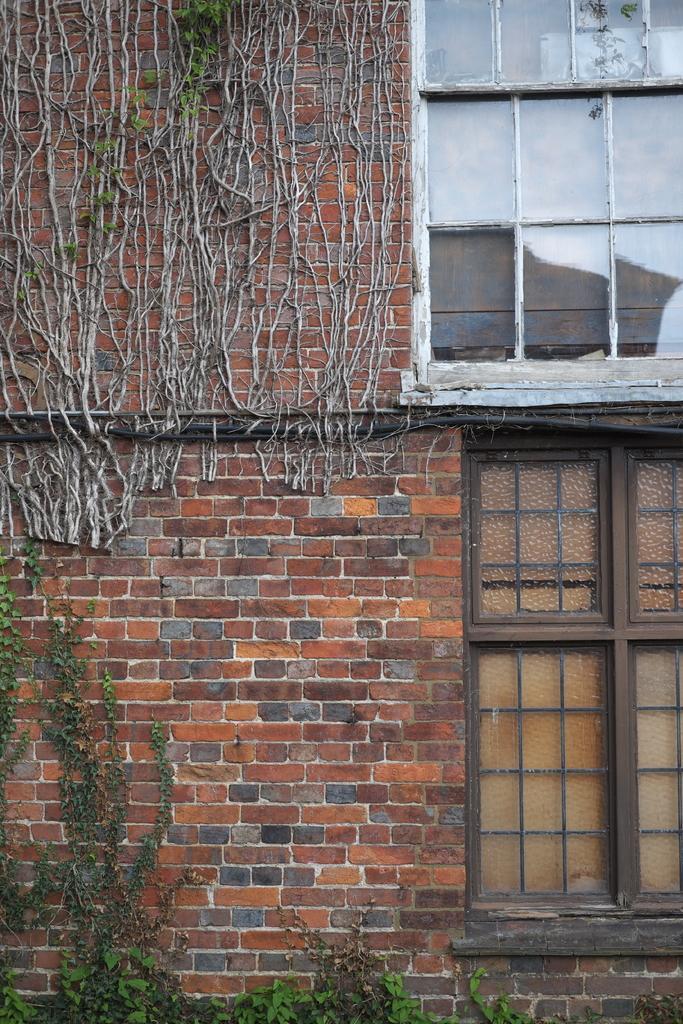In one or two sentences, can you explain what this image depicts? It is a brick wall, at the bottom there are plants. On the right side there are glass windows in this image. 